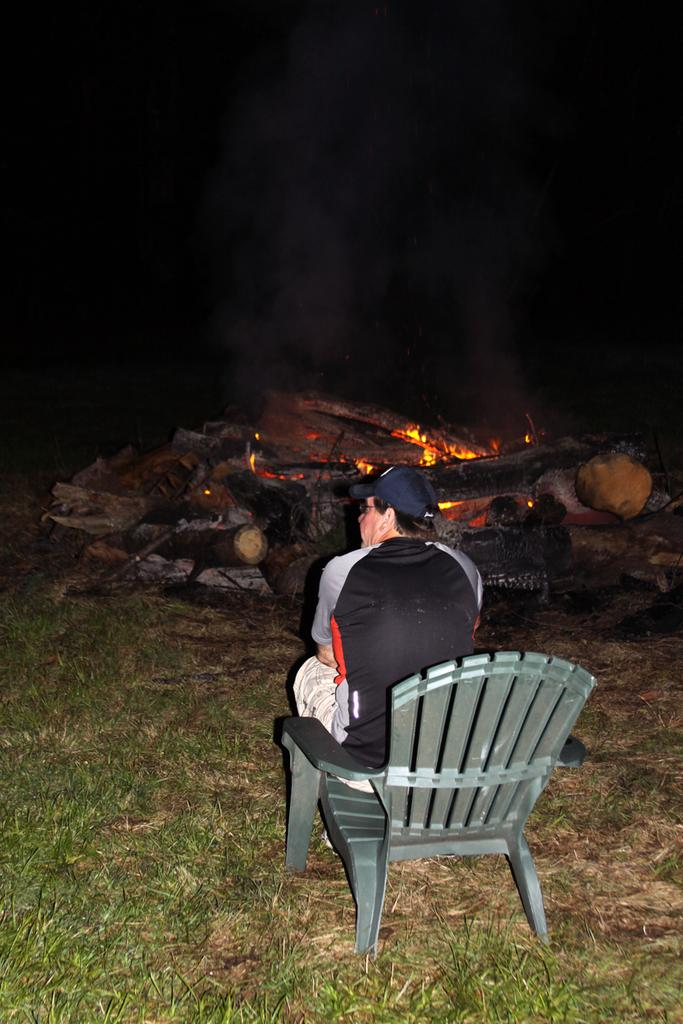What is the man in the foreground of the image doing? The man is sitting on a chair in the foreground of the image. Where is the chair located? The chair is on the ground. What can be seen in the background of the image? In the background, there is fire, sticks, smoke, and a dark setting. What type of vegetation is visible on the left side of the image? There is grass on the left side of the image. What type of science experiment is the man conducting with the bucket in the image? There is no bucket present in the image, and no science experiment is being conducted. 